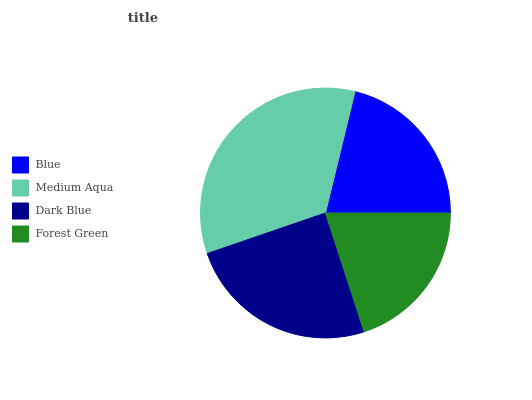Is Forest Green the minimum?
Answer yes or no. Yes. Is Medium Aqua the maximum?
Answer yes or no. Yes. Is Dark Blue the minimum?
Answer yes or no. No. Is Dark Blue the maximum?
Answer yes or no. No. Is Medium Aqua greater than Dark Blue?
Answer yes or no. Yes. Is Dark Blue less than Medium Aqua?
Answer yes or no. Yes. Is Dark Blue greater than Medium Aqua?
Answer yes or no. No. Is Medium Aqua less than Dark Blue?
Answer yes or no. No. Is Dark Blue the high median?
Answer yes or no. Yes. Is Blue the low median?
Answer yes or no. Yes. Is Forest Green the high median?
Answer yes or no. No. Is Forest Green the low median?
Answer yes or no. No. 